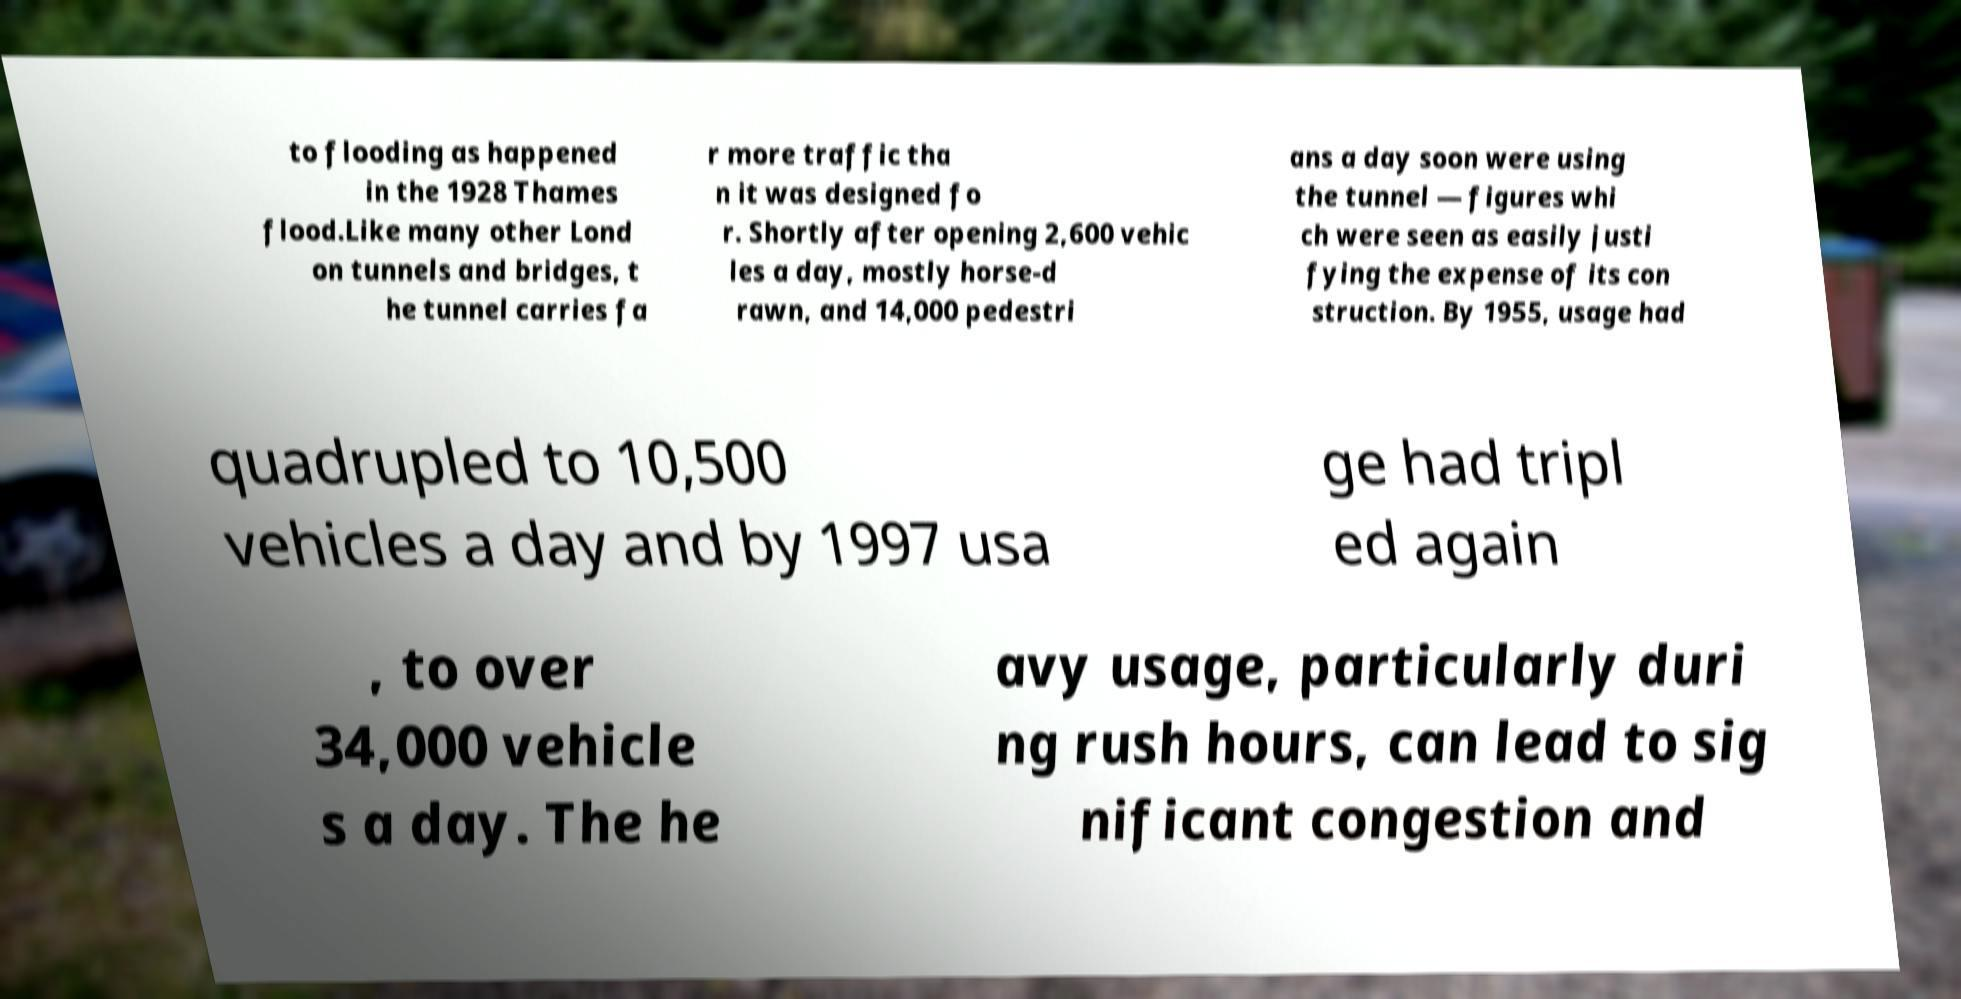Please read and relay the text visible in this image. What does it say? to flooding as happened in the 1928 Thames flood.Like many other Lond on tunnels and bridges, t he tunnel carries fa r more traffic tha n it was designed fo r. Shortly after opening 2,600 vehic les a day, mostly horse-d rawn, and 14,000 pedestri ans a day soon were using the tunnel — figures whi ch were seen as easily justi fying the expense of its con struction. By 1955, usage had quadrupled to 10,500 vehicles a day and by 1997 usa ge had tripl ed again , to over 34,000 vehicle s a day. The he avy usage, particularly duri ng rush hours, can lead to sig nificant congestion and 